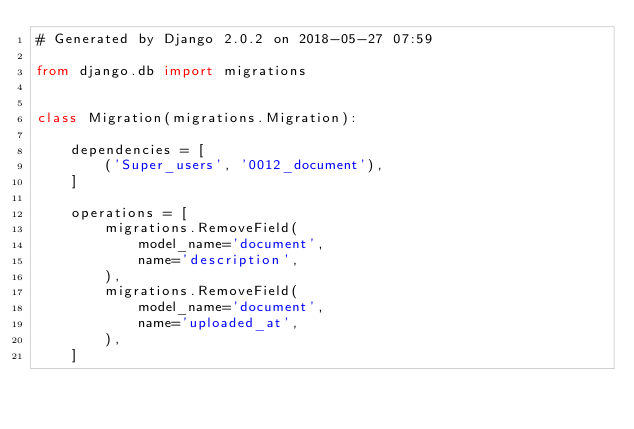<code> <loc_0><loc_0><loc_500><loc_500><_Python_># Generated by Django 2.0.2 on 2018-05-27 07:59

from django.db import migrations


class Migration(migrations.Migration):

    dependencies = [
        ('Super_users', '0012_document'),
    ]

    operations = [
        migrations.RemoveField(
            model_name='document',
            name='description',
        ),
        migrations.RemoveField(
            model_name='document',
            name='uploaded_at',
        ),
    ]
</code> 